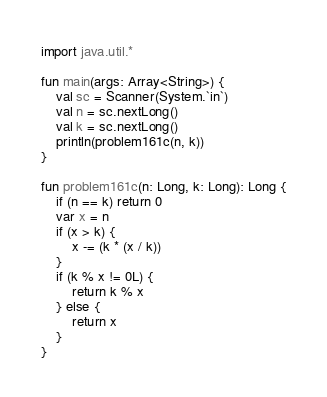<code> <loc_0><loc_0><loc_500><loc_500><_Kotlin_>import java.util.*

fun main(args: Array<String>) {
    val sc = Scanner(System.`in`)
    val n = sc.nextLong()
    val k = sc.nextLong()
    println(problem161c(n, k))
}

fun problem161c(n: Long, k: Long): Long {
    if (n == k) return 0
    var x = n
    if (x > k) {
        x -= (k * (x / k))
    }
    if (k % x != 0L) {
        return k % x
    } else {
        return x
    }
}</code> 